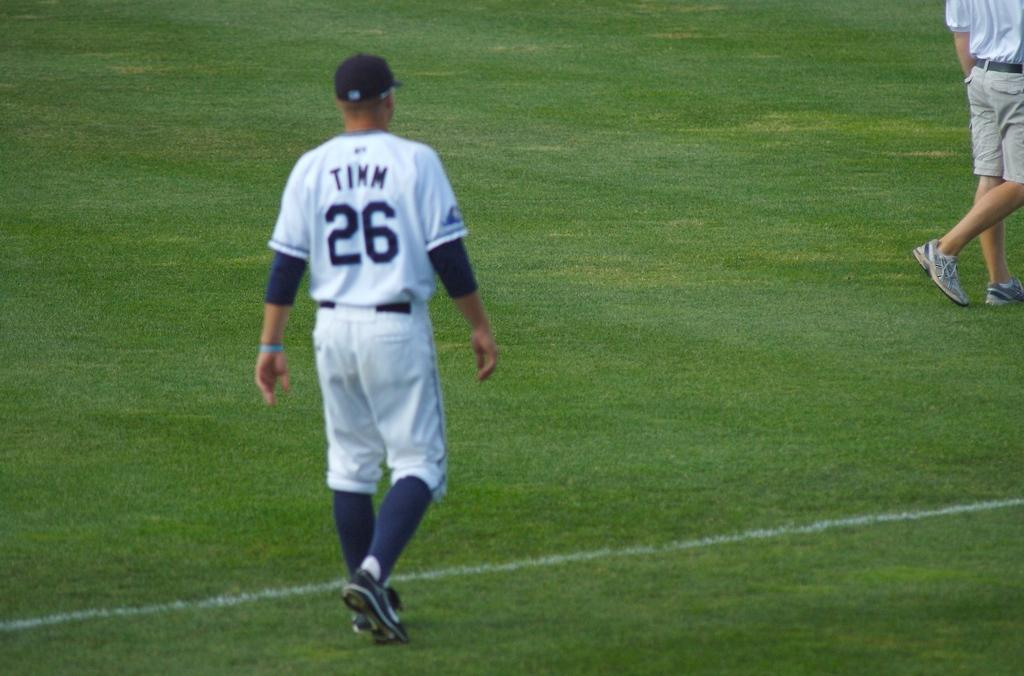<image>
Give a short and clear explanation of the subsequent image. A baseball player named Timm who wears number 26 walks on the field. 